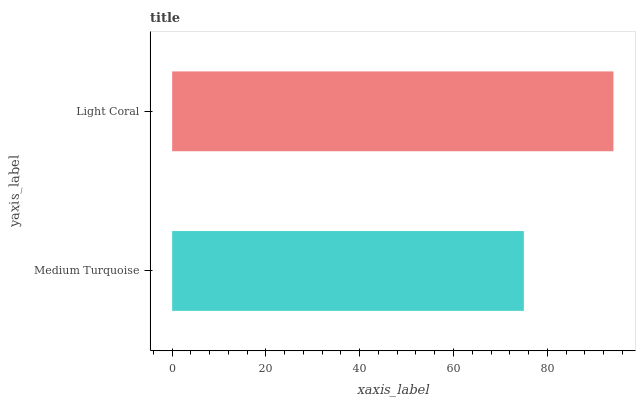Is Medium Turquoise the minimum?
Answer yes or no. Yes. Is Light Coral the maximum?
Answer yes or no. Yes. Is Light Coral the minimum?
Answer yes or no. No. Is Light Coral greater than Medium Turquoise?
Answer yes or no. Yes. Is Medium Turquoise less than Light Coral?
Answer yes or no. Yes. Is Medium Turquoise greater than Light Coral?
Answer yes or no. No. Is Light Coral less than Medium Turquoise?
Answer yes or no. No. Is Light Coral the high median?
Answer yes or no. Yes. Is Medium Turquoise the low median?
Answer yes or no. Yes. Is Medium Turquoise the high median?
Answer yes or no. No. Is Light Coral the low median?
Answer yes or no. No. 